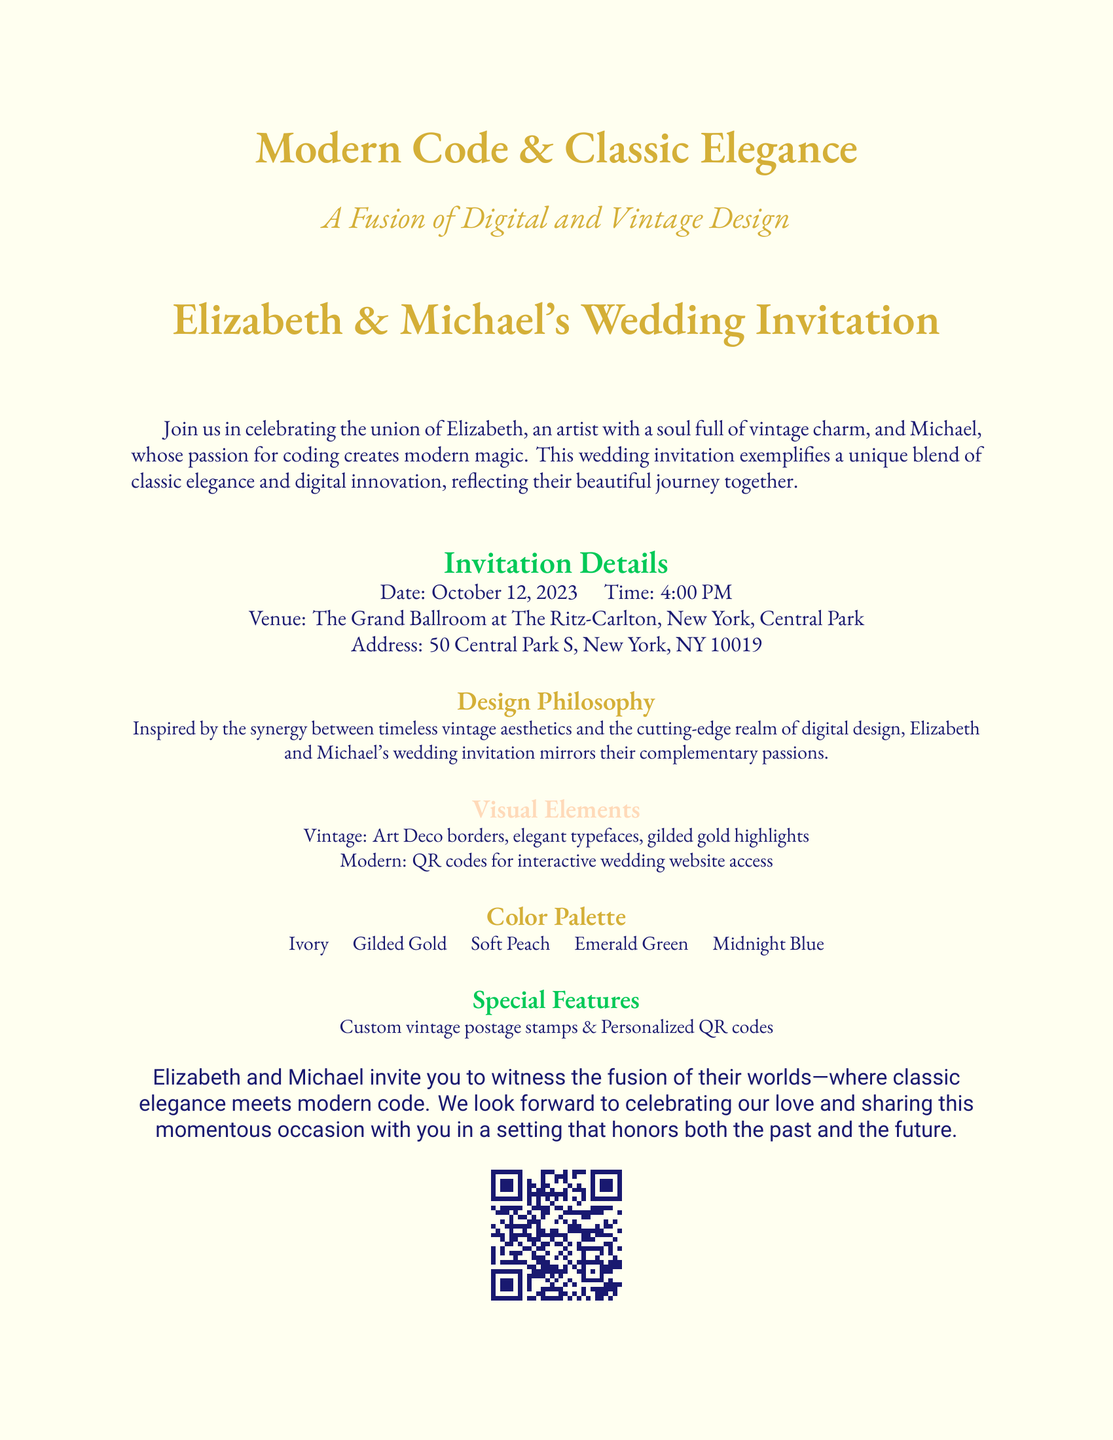What is the date of the wedding? The date is specifically mentioned in the invitation details as October 12, 2023.
Answer: October 12, 2023 What is the venue for the wedding? The venue is stated in the invitation details as The Grand Ballroom at The Ritz-Carlton, New York, Central Park.
Answer: The Grand Ballroom at The Ritz-Carlton, New York, Central Park Who are the couple getting married? The names of the couple are highlighted at the beginning of the document as Elizabeth and Michael.
Answer: Elizabeth and Michael What is the color palette used in the wedding invitation? The color palette is listed under its own section detailing the colors chosen for the design: Ivory, Gilded Gold, Soft Peach, Emerald Green, Midnight Blue.
Answer: Ivory, Gilded Gold, Soft Peach, Emerald Green, Midnight Blue What type of decorative elements are used for the vintage aspect? The document mentions Art Deco borders and elegant typefaces as part of the vintage design elements.
Answer: Art Deco borders, elegant typefaces What feature allows guests to access the wedding website? The invitation provides a specific modern feature, which is QR codes for interactive access.
Answer: QR codes What is the theme that combines both styles in the wedding invitation? The invitation describes a blend of classic elegance and modern code as the theme of the event.
Answer: A Fusion of Digital and Vintage Design What do the custom postage stamps represent? The custom postage stamps and personalized QR codes signify special features highlighting the couple's unique style.
Answer: Special features 